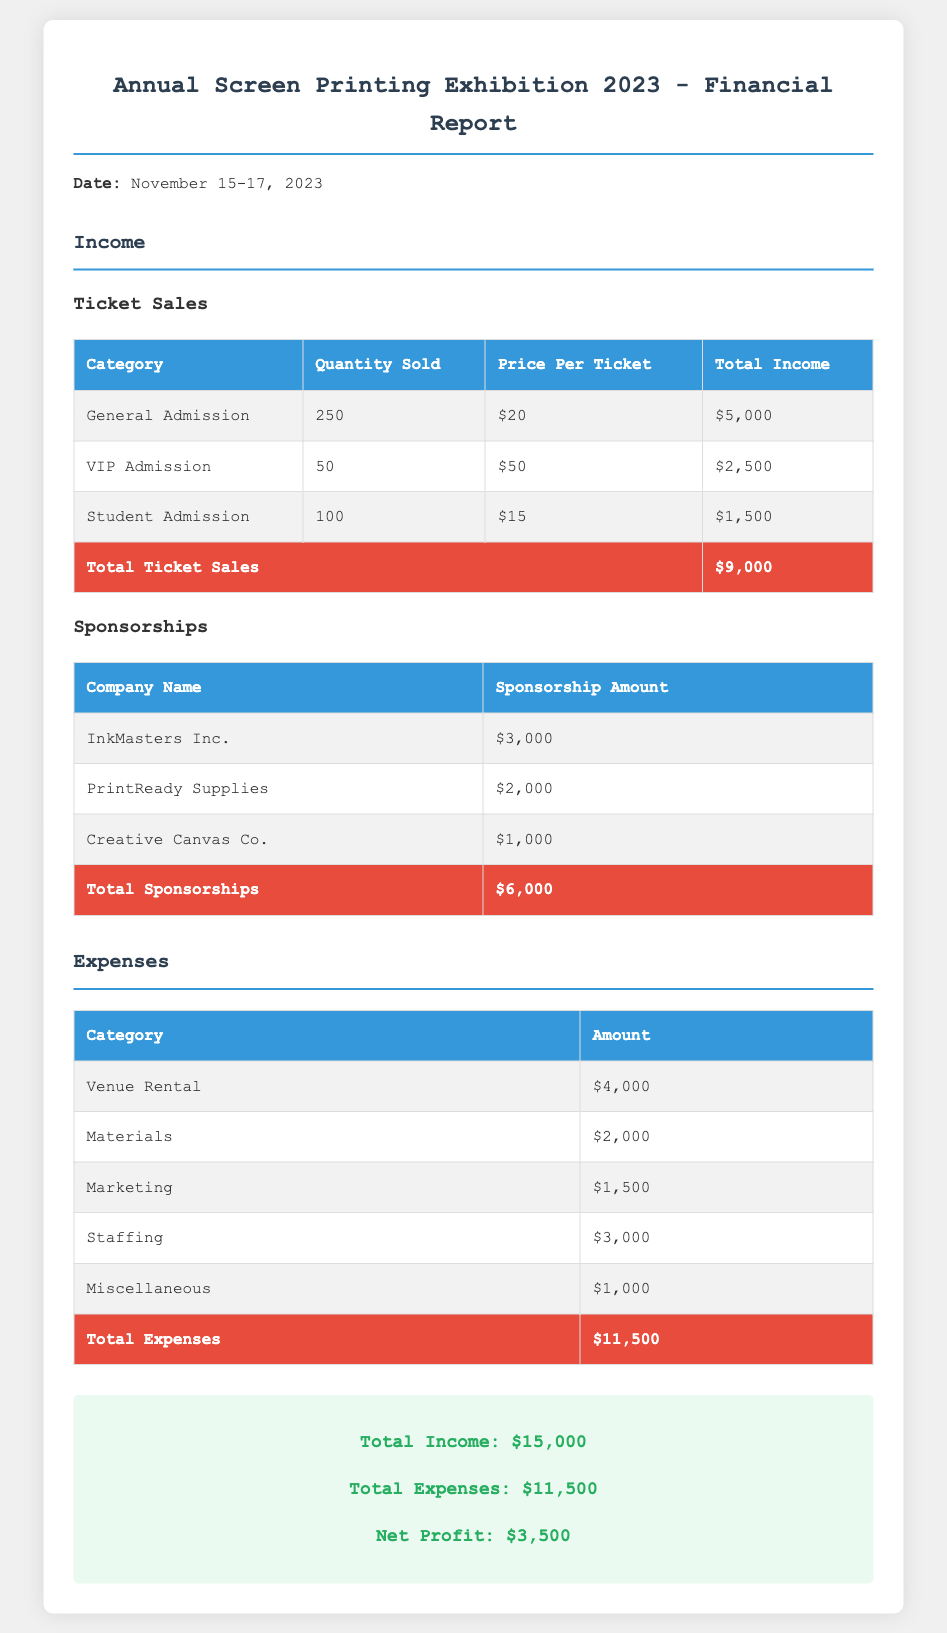What was the date of the exhibition? The date provided in the document is from November 15 to 17, 2023.
Answer: November 15-17, 2023 What is the total income from ticket sales? The total income from ticket sales is clearly mentioned in the income section of the document, which sums up all ticket sales.
Answer: $9,000 How many VIP tickets were sold? The document specifies the number of VIP tickets sold in the ticket sales table.
Answer: 50 What was the sponsorship amount from InkMasters Inc.? The sponsorship amount from InkMasters Inc. is stated in the sponsorships section of the document.
Answer: $3,000 What are the total expenses listed in the report? The total expenses are provided at the end of the expenses table, summing all expenses mentioned.
Answer: $11,500 What is the net profit for the exhibition? The net profit is calculated as total income minus total expenses, which is provided at the bottom of the document.
Answer: $3,500 Which company contributed the least in sponsorships? The sponsorship section lists all companies and their amounts, with the smallest one indicated.
Answer: Creative Canvas Co How much was collected from Student Admission tickets? This amount is clearly specified in the ticket sales table under Student Admission.
Answer: $1,500 What was the cost of venue rental? The venue rental expense is listed in the expenses table.
Answer: $4,000 